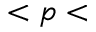<formula> <loc_0><loc_0><loc_500><loc_500>< p <</formula> 